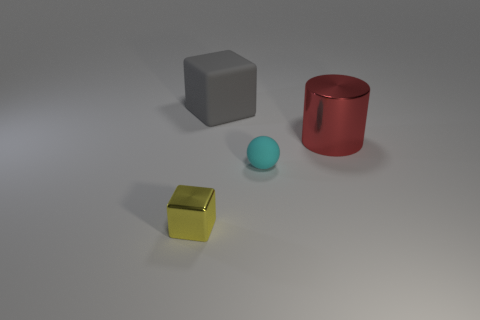Add 1 blue shiny spheres. How many objects exist? 5 Subtract all cylinders. How many objects are left? 3 Subtract all red objects. Subtract all small cyan matte things. How many objects are left? 2 Add 4 tiny cyan balls. How many tiny cyan balls are left? 5 Add 4 red shiny things. How many red shiny things exist? 5 Subtract 0 blue cubes. How many objects are left? 4 